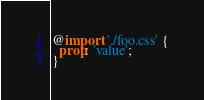<code> <loc_0><loc_0><loc_500><loc_500><_CSS_>@import './foo.css' {
  prop: 'value';
}
</code> 